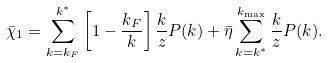Convert formula to latex. <formula><loc_0><loc_0><loc_500><loc_500>\bar { \chi } _ { 1 } = \sum _ { k = k _ { F } } ^ { k ^ { * } } \left [ 1 - \frac { k _ { F } } { k } \right ] \frac { k } { z } P ( k ) + \bar { \eta } \sum _ { k = k ^ { * } } ^ { k _ { \max } } \frac { k } { z } P ( k ) .</formula> 